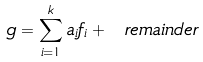Convert formula to latex. <formula><loc_0><loc_0><loc_500><loc_500>g = \sum _ { i = 1 } ^ { k } a _ { i } f _ { i } + \ r e m a i n d e r</formula> 